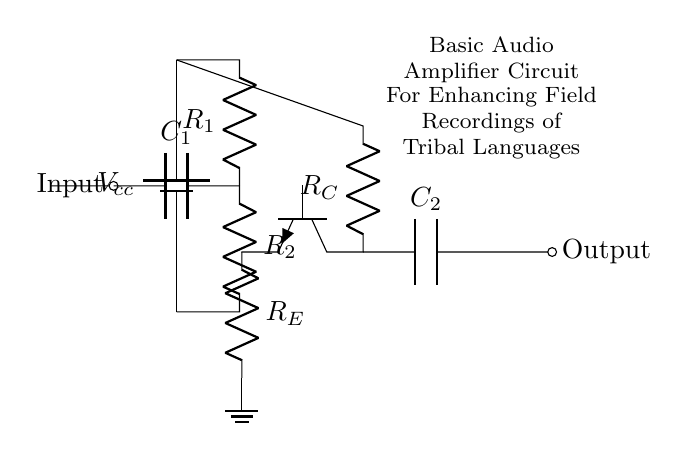What is the purpose of the coupling capacitors? The coupling capacitors, labeled C1 and C2, are used to allow AC signals to pass while blocking DC components. This ensures that only the audio (AC) signals are amplified without any DC offset affecting the output.
Answer: Allow AC signals What type of transistor is used in this circuit? The diagram shows an NPN transistor labeled Q1, indicated by the symbol and the specific labeling. An NPN transistor is used as it is common for amplification in audio applications.
Answer: NPN What does R_E represent in the circuit? R_E is the emitter resistor connected to the transistor Q1's emitter. It helps stabilize the operating point of the transistor and also impacts the gain of the amplifier.
Answer: Emitter resistor What is connected to the output of the amplifier? The output of the amplifier is connected to the capacitor C2, which then connects to the output node labeled "Output." It is used to provide a clean signal to the next stage or device.
Answer: C2 How many resistors are used in the amplifier circuit? There are two resistors in the amplifier circuit, labeled R1 and R2, which perform biasing functions for the base of the transistor Q1.
Answer: Two What is the voltage supply for this audio amplifier? The voltage supply for the circuit is indicated as V_cc, which represents the positive supply voltage necessary to power the amplifier. Although a specific value is not provided, this symbol indicates the power supply voltage.
Answer: V_cc What role do R1 and R2 play in this circuit? R1 and R2 are biasing resistors that set the proper biasing conditions for the transistor Q1. They help establish the correct operating point of the transistor to ensure linear amplification.
Answer: Biasing resistors 